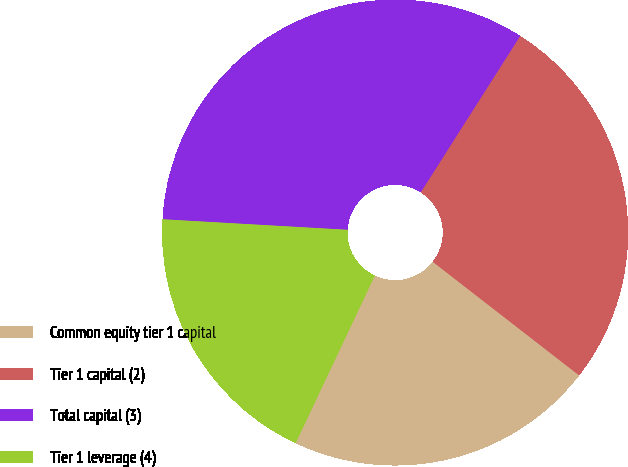Convert chart. <chart><loc_0><loc_0><loc_500><loc_500><pie_chart><fcel>Common equity tier 1 capital<fcel>Tier 1 capital (2)<fcel>Total capital (3)<fcel>Tier 1 leverage (4)<nl><fcel>21.52%<fcel>26.49%<fcel>33.11%<fcel>18.88%<nl></chart> 